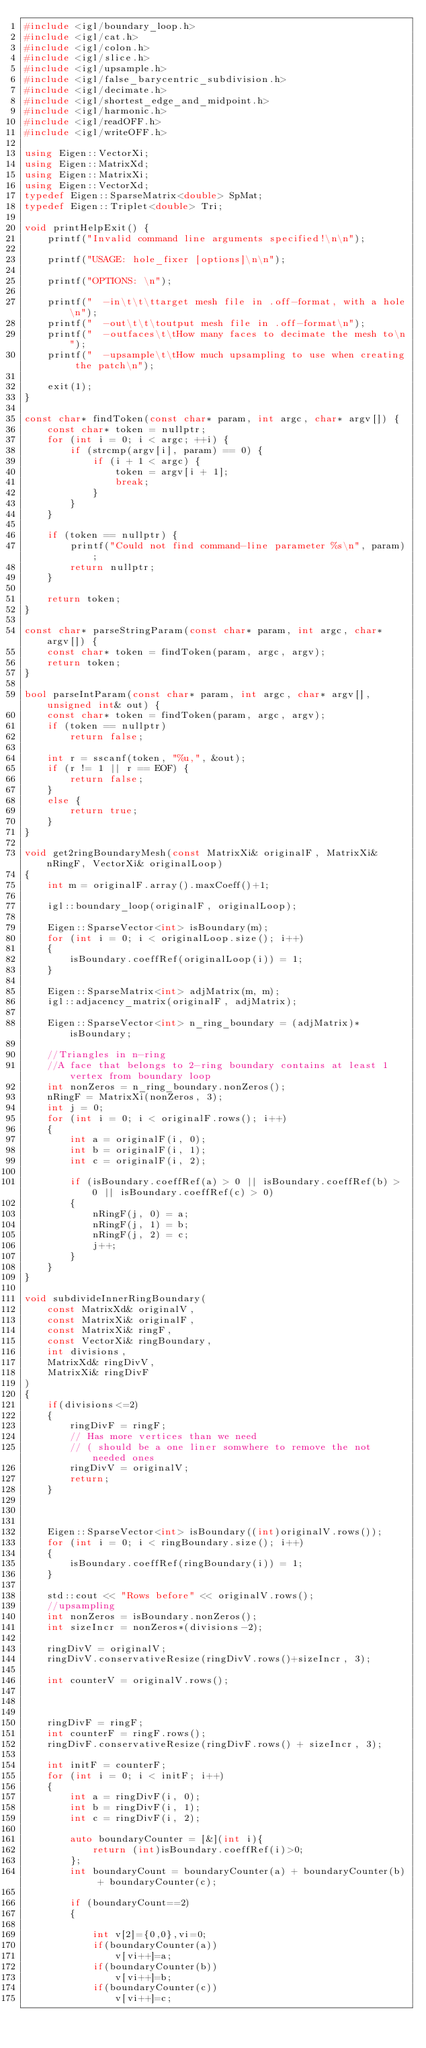Convert code to text. <code><loc_0><loc_0><loc_500><loc_500><_C++_>#include <igl/boundary_loop.h>
#include <igl/cat.h>
#include <igl/colon.h>
#include <igl/slice.h>
#include <igl/upsample.h>
#include <igl/false_barycentric_subdivision.h>
#include <igl/decimate.h>
#include <igl/shortest_edge_and_midpoint.h>
#include <igl/harmonic.h>
#include <igl/readOFF.h>
#include <igl/writeOFF.h>

using Eigen::VectorXi;
using Eigen::MatrixXd;
using Eigen::MatrixXi;
using Eigen::VectorXd;
typedef Eigen::SparseMatrix<double> SpMat;
typedef Eigen::Triplet<double> Tri;

void printHelpExit() {
	printf("Invalid command line arguments specified!\n\n");

	printf("USAGE: hole_fixer [options]\n\n");

	printf("OPTIONS: \n");

	printf("  -in\t\t\ttarget mesh file in .off-format, with a hole\n");
	printf("  -out\t\t\toutput mesh file in .off-format\n");
	printf("  -outfaces\t\tHow many faces to decimate the mesh to\n");
	printf("  -upsample\t\tHow much upsampling to use when creating the patch\n");

	exit(1);
}

const char* findToken(const char* param, int argc, char* argv[]) {
	const char* token = nullptr;
	for (int i = 0; i < argc; ++i) {
		if (strcmp(argv[i], param) == 0) {
			if (i + 1 < argc) {
				token = argv[i + 1];
				break;
			}
		}
	}

	if (token == nullptr) {
		printf("Could not find command-line parameter %s\n", param);
		return nullptr;
	}

	return token;
}

const char* parseStringParam(const char* param, int argc, char* argv[]) {
	const char* token = findToken(param, argc, argv);
	return token;
}

bool parseIntParam(const char* param, int argc, char* argv[], unsigned int& out) {
	const char* token = findToken(param, argc, argv);
	if (token == nullptr)
		return false;

	int r = sscanf(token, "%u,", &out);
	if (r != 1 || r == EOF) {
		return false;
	}
	else {
		return true;
	}
}

void get2ringBoundaryMesh(const MatrixXi& originalF, MatrixXi& nRingF, VectorXi& originalLoop)
{
	int m = originalF.array().maxCoeff()+1;
	
	igl::boundary_loop(originalF, originalLoop);	

	Eigen::SparseVector<int> isBoundary(m);
	for (int i = 0; i < originalLoop.size(); i++)
	{
		isBoundary.coeffRef(originalLoop(i)) = 1;
	}

	Eigen::SparseMatrix<int> adjMatrix(m, m);
	igl::adjacency_matrix(originalF, adjMatrix);

	Eigen::SparseVector<int> n_ring_boundary = (adjMatrix)* isBoundary;

	//Triangles in n-ring
	//A face that belongs to 2-ring boundary contains at least 1 vertex from boundary loop
	int nonZeros = n_ring_boundary.nonZeros();
	nRingF = MatrixXi(nonZeros, 3);
	int j = 0;
	for (int i = 0; i < originalF.rows(); i++)
	{
		int a = originalF(i, 0);
		int b = originalF(i, 1);
		int c = originalF(i, 2);

		if (isBoundary.coeffRef(a) > 0 || isBoundary.coeffRef(b) > 0 || isBoundary.coeffRef(c) > 0)
		{
			nRingF(j, 0) = a;
			nRingF(j, 1) = b;
			nRingF(j, 2) = c;
			j++;
		}
	}
}

void subdivideInnerRingBoundary(
	const MatrixXd& originalV, 
	const MatrixXi& originalF, 
	const MatrixXi& ringF,
	const VectorXi& ringBoundary,
	int divisions,
	MatrixXd& ringDivV,
	MatrixXi& ringDivF
)
{
	if(divisions<=2)
	{
		ringDivF = ringF;
		// Has more vertices than we need 
		// ( should be a one liner somwhere to remove the not needed ones
		ringDivV = originalV; 
		return;
	}
	


	Eigen::SparseVector<int> isBoundary((int)originalV.rows());
	for (int i = 0; i < ringBoundary.size(); i++)
	{
		isBoundary.coeffRef(ringBoundary(i)) = 1;
	}

	std::cout << "Rows before" << originalV.rows();
	//upsampling 
	int nonZeros = isBoundary.nonZeros();
	int sizeIncr = nonZeros*(divisions-2);

	ringDivV = originalV;
	ringDivV.conservativeResize(ringDivV.rows()+sizeIncr, 3);

	int counterV = originalV.rows();

	

	ringDivF = ringF;
    int counterF = ringF.rows();
	ringDivF.conservativeResize(ringDivF.rows() + sizeIncr, 3);

	int initF = counterF;
	for (int i = 0; i < initF; i++)
	{
		int a = ringDivF(i, 0);
		int b = ringDivF(i, 1);
		int c = ringDivF(i, 2);
		
		auto boundaryCounter = [&](int i){
		    return (int)isBoundary.coeffRef(i)>0;
		};
		int boundaryCount = boundaryCounter(a) + boundaryCounter(b) + boundaryCounter(c);

		if (boundaryCount==2)
		{
						
			int v[2]={0,0},vi=0;
			if(boundaryCounter(a))
				v[vi++]=a;
			if(boundaryCounter(b))
				v[vi++]=b;
			if(boundaryCounter(c))
				v[vi++]=c;
</code> 